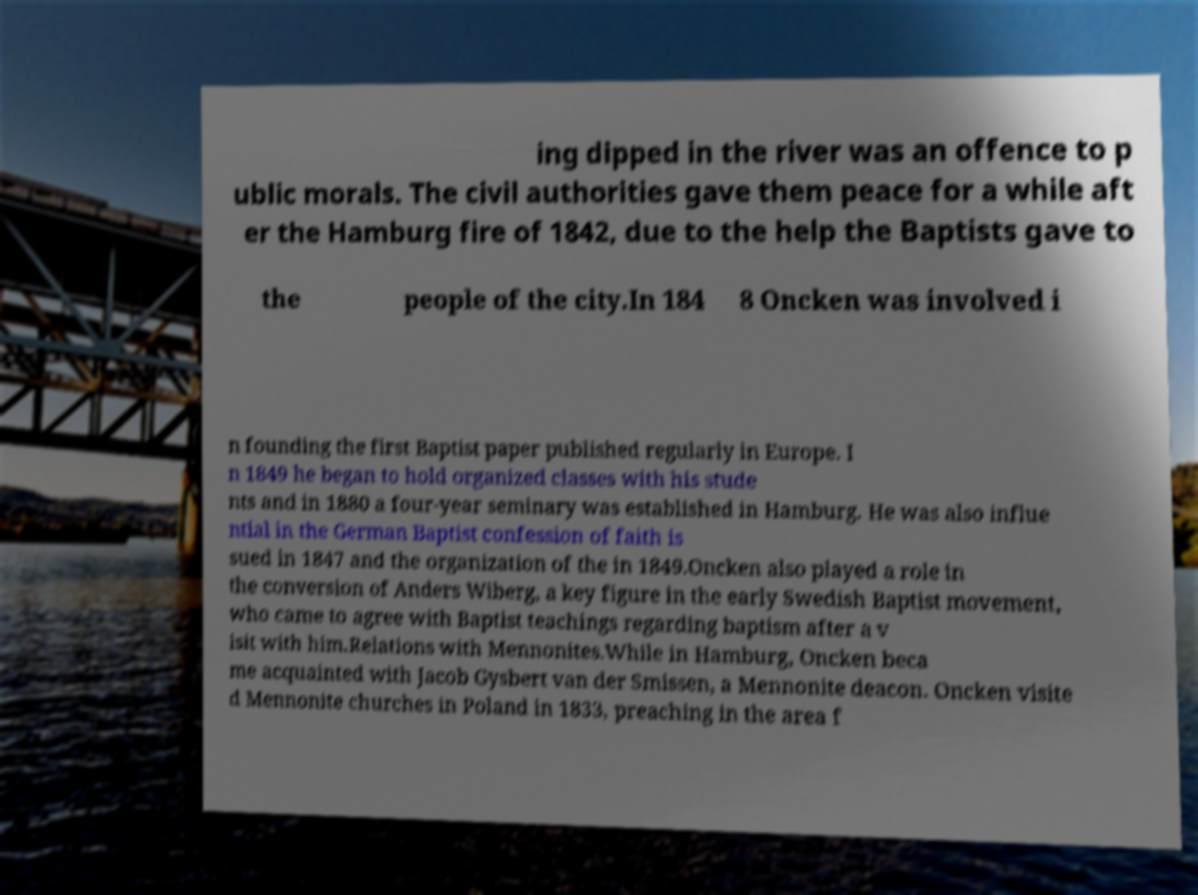I need the written content from this picture converted into text. Can you do that? ing dipped in the river was an offence to p ublic morals. The civil authorities gave them peace for a while aft er the Hamburg fire of 1842, due to the help the Baptists gave to the people of the city.In 184 8 Oncken was involved i n founding the first Baptist paper published regularly in Europe. I n 1849 he began to hold organized classes with his stude nts and in 1880 a four-year seminary was established in Hamburg. He was also influe ntial in the German Baptist confession of faith is sued in 1847 and the organization of the in 1849.Oncken also played a role in the conversion of Anders Wiberg, a key figure in the early Swedish Baptist movement, who came to agree with Baptist teachings regarding baptism after a v isit with him.Relations with Mennonites.While in Hamburg, Oncken beca me acquainted with Jacob Gysbert van der Smissen, a Mennonite deacon. Oncken visite d Mennonite churches in Poland in 1833, preaching in the area f 